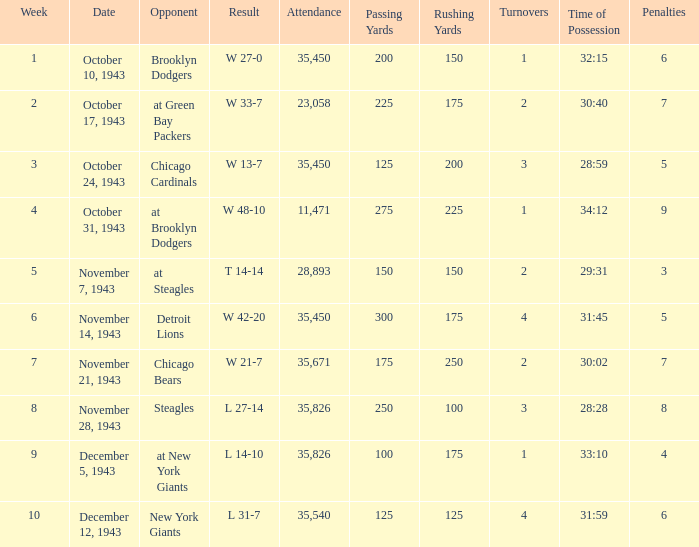What is the lowest week that has an attendance greater than 23,058, with october 24, 1943 as the date? 3.0. Help me parse the entirety of this table. {'header': ['Week', 'Date', 'Opponent', 'Result', 'Attendance', 'Passing Yards', 'Rushing Yards', 'Turnovers', 'Time of Possession', 'Penalties'], 'rows': [['1', 'October 10, 1943', 'Brooklyn Dodgers', 'W 27-0', '35,450', '200', '150', '1', '32:15', '6'], ['2', 'October 17, 1943', 'at Green Bay Packers', 'W 33-7', '23,058', '225', '175', '2', '30:40', '7'], ['3', 'October 24, 1943', 'Chicago Cardinals', 'W 13-7', '35,450', '125', '200', '3', '28:59', '5'], ['4', 'October 31, 1943', 'at Brooklyn Dodgers', 'W 48-10', '11,471', '275', '225', '1', '34:12', '9'], ['5', 'November 7, 1943', 'at Steagles', 'T 14-14', '28,893', '150', '150', '2', '29:31', '3'], ['6', 'November 14, 1943', 'Detroit Lions', 'W 42-20', '35,450', '300', '175', '4', '31:45', '5'], ['7', 'November 21, 1943', 'Chicago Bears', 'W 21-7', '35,671', '175', '250', '2', '30:02', '7'], ['8', 'November 28, 1943', 'Steagles', 'L 27-14', '35,826', '250', '100', '3', '28:28', '8'], ['9', 'December 5, 1943', 'at New York Giants', 'L 14-10', '35,826', '100', '175', '1', '33:10', '4'], ['10', 'December 12, 1943', 'New York Giants', 'L 31-7', '35,540', '125', '125', '4', '31:59', '6']]} 